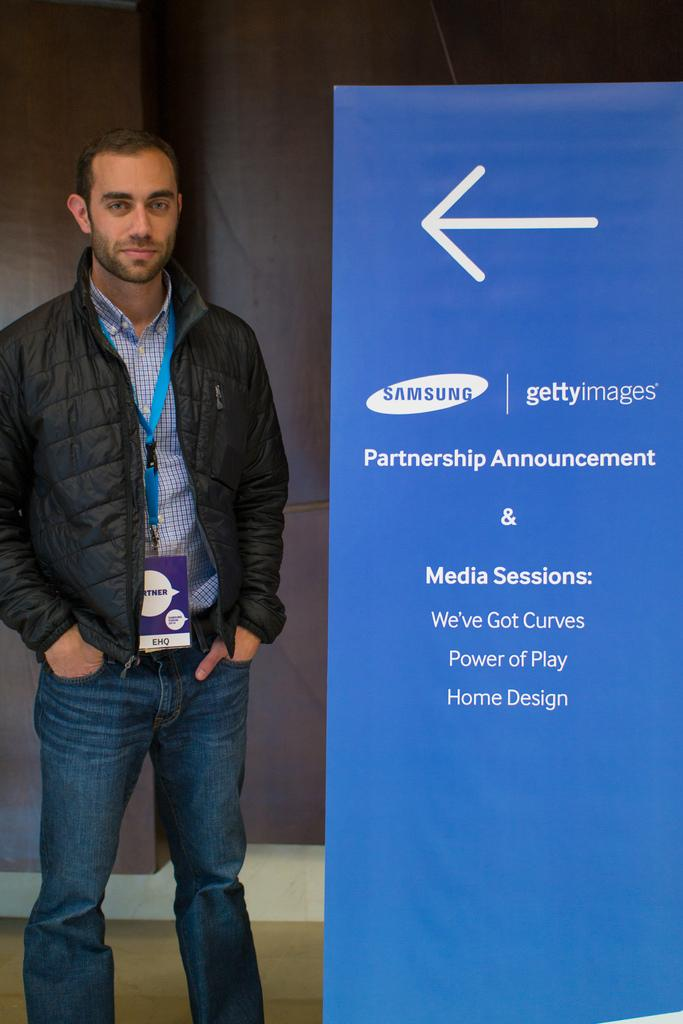Who is present in the image? There is a man in the image. What is the man's facial expression? The man has a smiling face. What is the man doing in the image? The man is standing. What is the man wearing that identifies him? The man is wearing an ID card. What can be seen on the floor in the image? There is a blue board with text on the floor. What is visible in the background of the image? There is a big wall in the background. What type of grass is growing on the man's head in the image? There is no grass growing on the man's head in the image. Is there any poison visible in the image? There is no poison present in the image. 